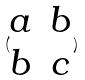<formula> <loc_0><loc_0><loc_500><loc_500>( \begin{matrix} a & b \\ b & c \end{matrix} )</formula> 